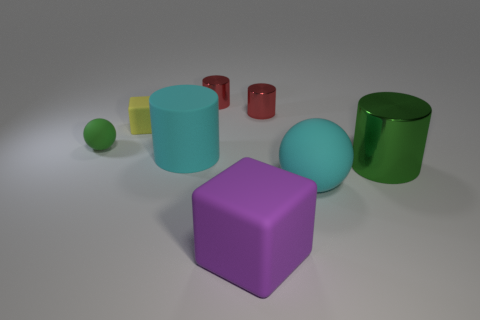How many metallic objects are green balls or cylinders?
Keep it short and to the point. 3. There is a matte object that is both on the left side of the cyan matte cylinder and to the right of the green matte object; what color is it?
Provide a succinct answer. Yellow. There is a green object that is in front of the cyan cylinder; does it have the same size as the yellow object?
Offer a very short reply. No. What number of objects are either tiny things that are in front of the tiny matte cube or big objects?
Make the answer very short. 5. Is there another yellow rubber object of the same size as the yellow rubber object?
Keep it short and to the point. No. There is a green cylinder that is the same size as the purple matte thing; what is it made of?
Offer a terse response. Metal. There is a thing that is in front of the yellow object and on the left side of the matte cylinder; what is its shape?
Your answer should be very brief. Sphere. What is the color of the ball that is behind the green cylinder?
Your response must be concise. Green. What size is the cylinder that is both in front of the yellow rubber thing and to the right of the big rubber cube?
Make the answer very short. Large. Does the purple cube have the same material as the big cylinder behind the large metallic thing?
Provide a short and direct response. Yes. 